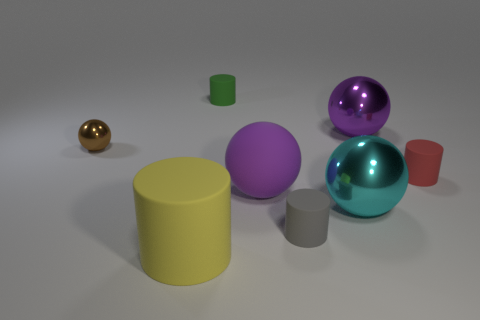What time of day or lighting setup is suggested by the shadows in the image? The shadows in the image are soft and diffuse, implying an indoor setting with ambient lighting, perhaps from overhead light sources, rather than a specific time of day. 